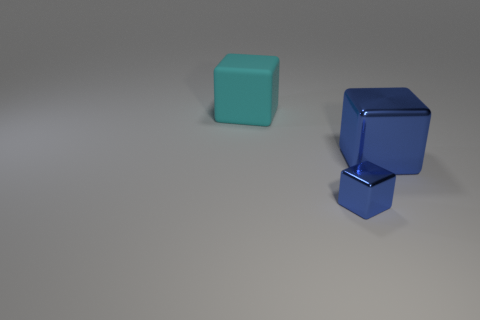Is the number of rubber blocks on the right side of the big cyan cube less than the number of metallic things behind the tiny blue thing?
Keep it short and to the point. Yes. What is the material of the object to the left of the blue metal thing that is in front of the blue block right of the small shiny object?
Your response must be concise. Rubber. What size is the object that is left of the big blue thing and in front of the large rubber cube?
Ensure brevity in your answer.  Small. How many spheres are either big cyan objects or small metallic objects?
Ensure brevity in your answer.  0. There is a object that is the same size as the matte cube; what is its color?
Offer a terse response. Blue. There is another small metal thing that is the same shape as the cyan thing; what color is it?
Keep it short and to the point. Blue. How many things are either tiny blue metallic cylinders or metal things on the right side of the small metal object?
Your response must be concise. 1. Is the number of blue cubes to the left of the tiny blue metal block less than the number of cyan rubber cylinders?
Your answer should be very brief. No. What size is the shiny object left of the large thing in front of the large cube on the left side of the small cube?
Your answer should be compact. Small. What is the color of the cube that is in front of the large cyan object and behind the tiny blue block?
Make the answer very short. Blue. 